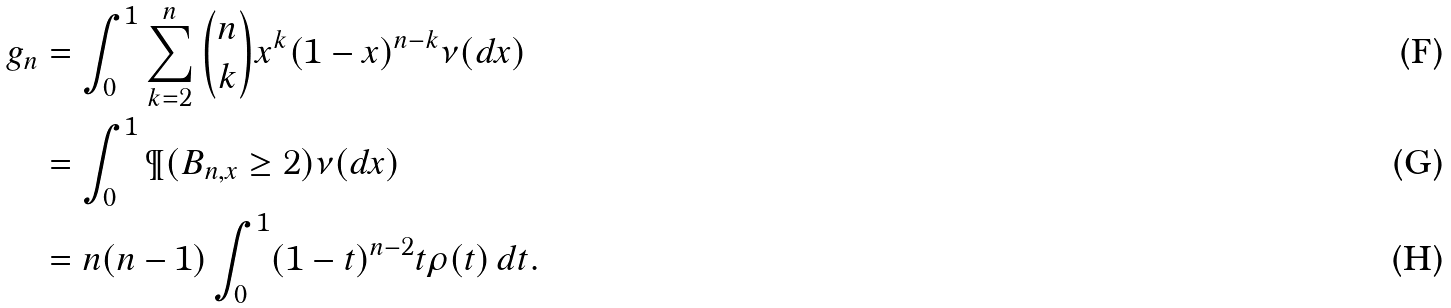<formula> <loc_0><loc_0><loc_500><loc_500>g _ { n } & = \int _ { 0 } ^ { 1 } \sum _ { k = 2 } ^ { n } \binom { n } { k } x ^ { k } ( 1 - x ) ^ { n - k } \nu ( d x ) \\ & = \int _ { 0 } ^ { 1 } \P ( B _ { n , x } \geq 2 ) \nu ( d x ) \\ & = n ( n - 1 ) \int _ { 0 } ^ { 1 } ( 1 - t ) ^ { n - 2 } t \rho ( t ) \, d t .</formula> 